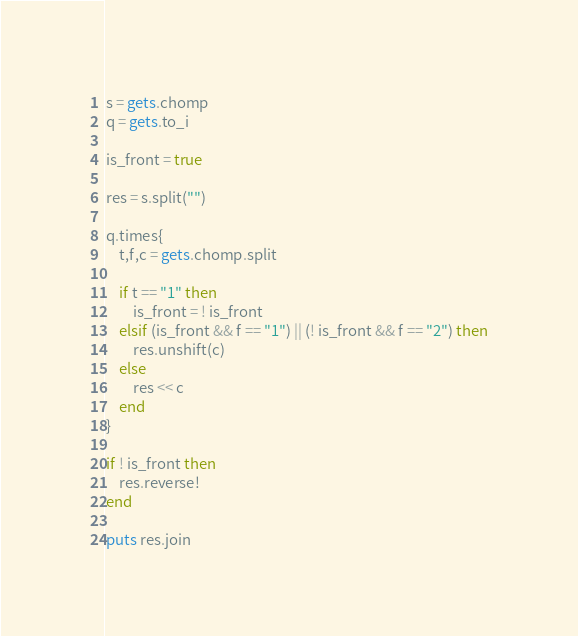<code> <loc_0><loc_0><loc_500><loc_500><_Ruby_>s = gets.chomp
q = gets.to_i

is_front = true

res = s.split("")

q.times{
	t,f,c = gets.chomp.split

	if t == "1" then
		is_front = ! is_front
	elsif (is_front && f == "1") || (! is_front && f == "2") then
		res.unshift(c)
	else
		res << c
	end
}

if ! is_front then
	res.reverse!
end

puts res.join</code> 